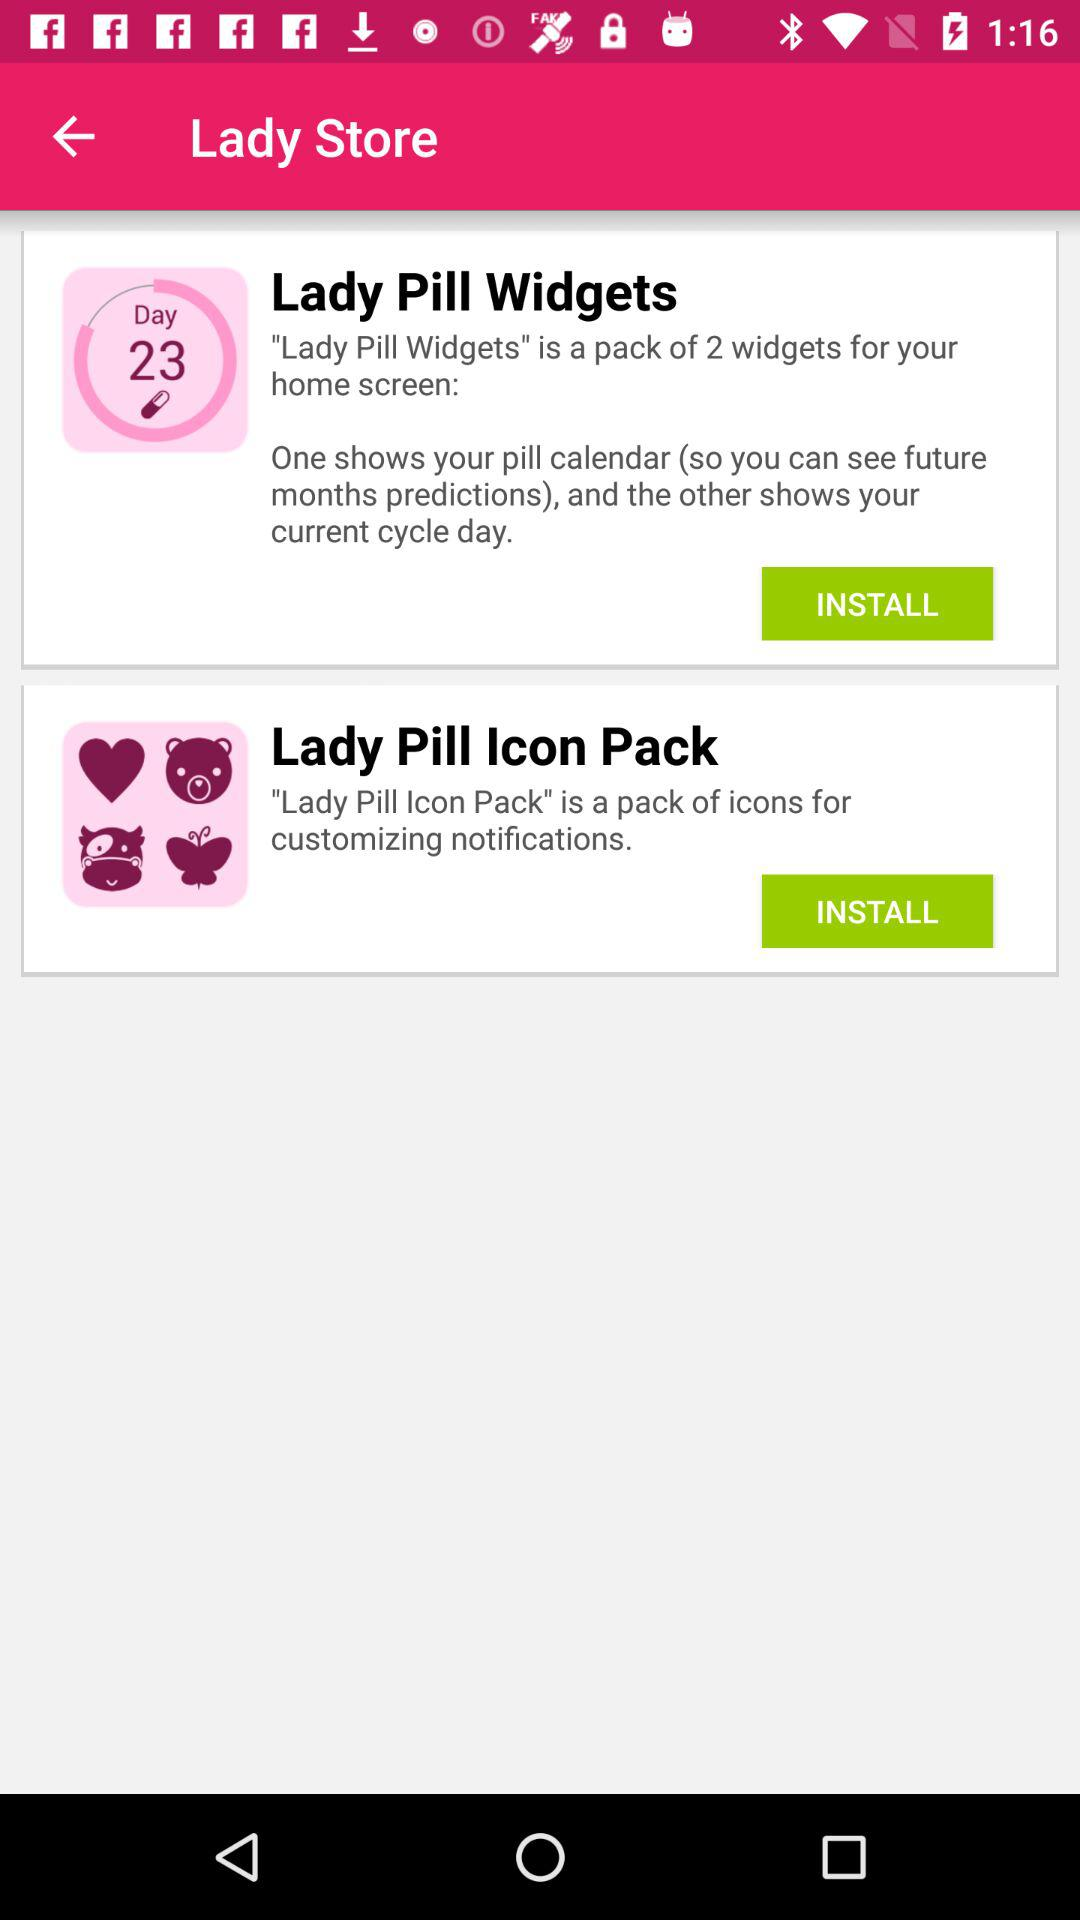How many days are shown? The shown days are 23. 